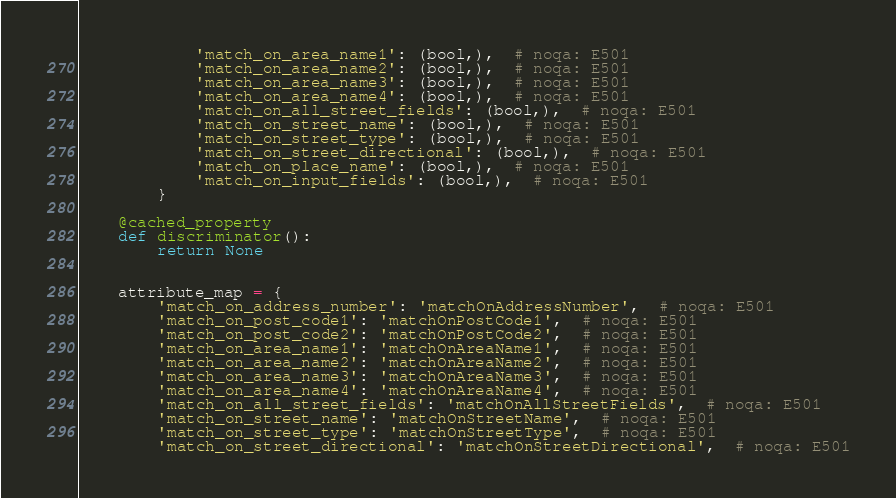<code> <loc_0><loc_0><loc_500><loc_500><_Python_>            'match_on_area_name1': (bool,),  # noqa: E501
            'match_on_area_name2': (bool,),  # noqa: E501
            'match_on_area_name3': (bool,),  # noqa: E501
            'match_on_area_name4': (bool,),  # noqa: E501
            'match_on_all_street_fields': (bool,),  # noqa: E501
            'match_on_street_name': (bool,),  # noqa: E501
            'match_on_street_type': (bool,),  # noqa: E501
            'match_on_street_directional': (bool,),  # noqa: E501
            'match_on_place_name': (bool,),  # noqa: E501
            'match_on_input_fields': (bool,),  # noqa: E501
        }

    @cached_property
    def discriminator():
        return None


    attribute_map = {
        'match_on_address_number': 'matchOnAddressNumber',  # noqa: E501
        'match_on_post_code1': 'matchOnPostCode1',  # noqa: E501
        'match_on_post_code2': 'matchOnPostCode2',  # noqa: E501
        'match_on_area_name1': 'matchOnAreaName1',  # noqa: E501
        'match_on_area_name2': 'matchOnAreaName2',  # noqa: E501
        'match_on_area_name3': 'matchOnAreaName3',  # noqa: E501
        'match_on_area_name4': 'matchOnAreaName4',  # noqa: E501
        'match_on_all_street_fields': 'matchOnAllStreetFields',  # noqa: E501
        'match_on_street_name': 'matchOnStreetName',  # noqa: E501
        'match_on_street_type': 'matchOnStreetType',  # noqa: E501
        'match_on_street_directional': 'matchOnStreetDirectional',  # noqa: E501</code> 